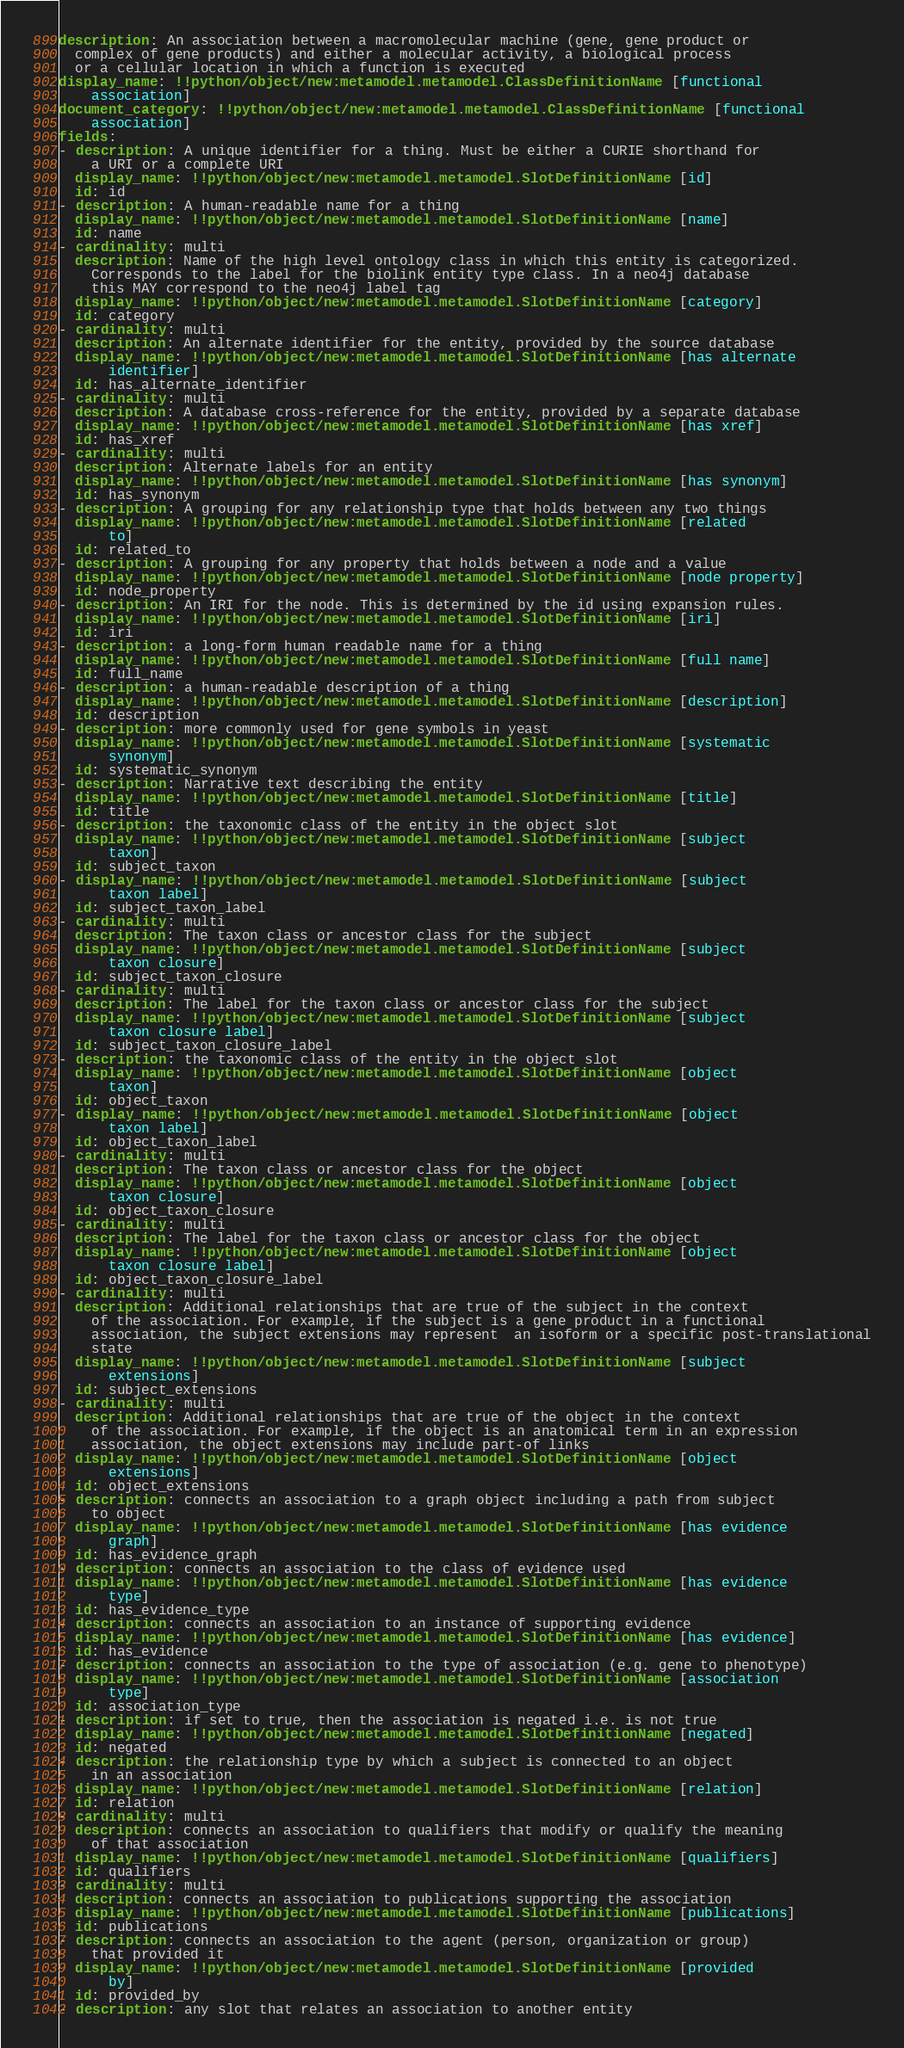Convert code to text. <code><loc_0><loc_0><loc_500><loc_500><_YAML_>description: An association between a macromolecular machine (gene, gene product or
  complex of gene products) and either a molecular activity, a biological process
  or a cellular location in which a function is executed
display_name: !!python/object/new:metamodel.metamodel.ClassDefinitionName [functional
    association]
document_category: !!python/object/new:metamodel.metamodel.ClassDefinitionName [functional
    association]
fields:
- description: A unique identifier for a thing. Must be either a CURIE shorthand for
    a URI or a complete URI
  display_name: !!python/object/new:metamodel.metamodel.SlotDefinitionName [id]
  id: id
- description: A human-readable name for a thing
  display_name: !!python/object/new:metamodel.metamodel.SlotDefinitionName [name]
  id: name
- cardinality: multi
  description: Name of the high level ontology class in which this entity is categorized.
    Corresponds to the label for the biolink entity type class. In a neo4j database
    this MAY correspond to the neo4j label tag
  display_name: !!python/object/new:metamodel.metamodel.SlotDefinitionName [category]
  id: category
- cardinality: multi
  description: An alternate identifier for the entity, provided by the source database
  display_name: !!python/object/new:metamodel.metamodel.SlotDefinitionName [has alternate
      identifier]
  id: has_alternate_identifier
- cardinality: multi
  description: A database cross-reference for the entity, provided by a separate database
  display_name: !!python/object/new:metamodel.metamodel.SlotDefinitionName [has xref]
  id: has_xref
- cardinality: multi
  description: Alternate labels for an entity
  display_name: !!python/object/new:metamodel.metamodel.SlotDefinitionName [has synonym]
  id: has_synonym
- description: A grouping for any relationship type that holds between any two things
  display_name: !!python/object/new:metamodel.metamodel.SlotDefinitionName [related
      to]
  id: related_to
- description: A grouping for any property that holds between a node and a value
  display_name: !!python/object/new:metamodel.metamodel.SlotDefinitionName [node property]
  id: node_property
- description: An IRI for the node. This is determined by the id using expansion rules.
  display_name: !!python/object/new:metamodel.metamodel.SlotDefinitionName [iri]
  id: iri
- description: a long-form human readable name for a thing
  display_name: !!python/object/new:metamodel.metamodel.SlotDefinitionName [full name]
  id: full_name
- description: a human-readable description of a thing
  display_name: !!python/object/new:metamodel.metamodel.SlotDefinitionName [description]
  id: description
- description: more commonly used for gene symbols in yeast
  display_name: !!python/object/new:metamodel.metamodel.SlotDefinitionName [systematic
      synonym]
  id: systematic_synonym
- description: Narrative text describing the entity
  display_name: !!python/object/new:metamodel.metamodel.SlotDefinitionName [title]
  id: title
- description: the taxonomic class of the entity in the object slot
  display_name: !!python/object/new:metamodel.metamodel.SlotDefinitionName [subject
      taxon]
  id: subject_taxon
- display_name: !!python/object/new:metamodel.metamodel.SlotDefinitionName [subject
      taxon label]
  id: subject_taxon_label
- cardinality: multi
  description: The taxon class or ancestor class for the subject
  display_name: !!python/object/new:metamodel.metamodel.SlotDefinitionName [subject
      taxon closure]
  id: subject_taxon_closure
- cardinality: multi
  description: The label for the taxon class or ancestor class for the subject
  display_name: !!python/object/new:metamodel.metamodel.SlotDefinitionName [subject
      taxon closure label]
  id: subject_taxon_closure_label
- description: the taxonomic class of the entity in the object slot
  display_name: !!python/object/new:metamodel.metamodel.SlotDefinitionName [object
      taxon]
  id: object_taxon
- display_name: !!python/object/new:metamodel.metamodel.SlotDefinitionName [object
      taxon label]
  id: object_taxon_label
- cardinality: multi
  description: The taxon class or ancestor class for the object
  display_name: !!python/object/new:metamodel.metamodel.SlotDefinitionName [object
      taxon closure]
  id: object_taxon_closure
- cardinality: multi
  description: The label for the taxon class or ancestor class for the object
  display_name: !!python/object/new:metamodel.metamodel.SlotDefinitionName [object
      taxon closure label]
  id: object_taxon_closure_label
- cardinality: multi
  description: Additional relationships that are true of the subject in the context
    of the association. For example, if the subject is a gene product in a functional
    association, the subject extensions may represent  an isoform or a specific post-translational
    state
  display_name: !!python/object/new:metamodel.metamodel.SlotDefinitionName [subject
      extensions]
  id: subject_extensions
- cardinality: multi
  description: Additional relationships that are true of the object in the context
    of the association. For example, if the object is an anatomical term in an expression
    association, the object extensions may include part-of links
  display_name: !!python/object/new:metamodel.metamodel.SlotDefinitionName [object
      extensions]
  id: object_extensions
- description: connects an association to a graph object including a path from subject
    to object
  display_name: !!python/object/new:metamodel.metamodel.SlotDefinitionName [has evidence
      graph]
  id: has_evidence_graph
- description: connects an association to the class of evidence used
  display_name: !!python/object/new:metamodel.metamodel.SlotDefinitionName [has evidence
      type]
  id: has_evidence_type
- description: connects an association to an instance of supporting evidence
  display_name: !!python/object/new:metamodel.metamodel.SlotDefinitionName [has evidence]
  id: has_evidence
- description: connects an association to the type of association (e.g. gene to phenotype)
  display_name: !!python/object/new:metamodel.metamodel.SlotDefinitionName [association
      type]
  id: association_type
- description: if set to true, then the association is negated i.e. is not true
  display_name: !!python/object/new:metamodel.metamodel.SlotDefinitionName [negated]
  id: negated
- description: the relationship type by which a subject is connected to an object
    in an association
  display_name: !!python/object/new:metamodel.metamodel.SlotDefinitionName [relation]
  id: relation
- cardinality: multi
  description: connects an association to qualifiers that modify or qualify the meaning
    of that association
  display_name: !!python/object/new:metamodel.metamodel.SlotDefinitionName [qualifiers]
  id: qualifiers
- cardinality: multi
  description: connects an association to publications supporting the association
  display_name: !!python/object/new:metamodel.metamodel.SlotDefinitionName [publications]
  id: publications
- description: connects an association to the agent (person, organization or group)
    that provided it
  display_name: !!python/object/new:metamodel.metamodel.SlotDefinitionName [provided
      by]
  id: provided_by
- description: any slot that relates an association to another entity</code> 